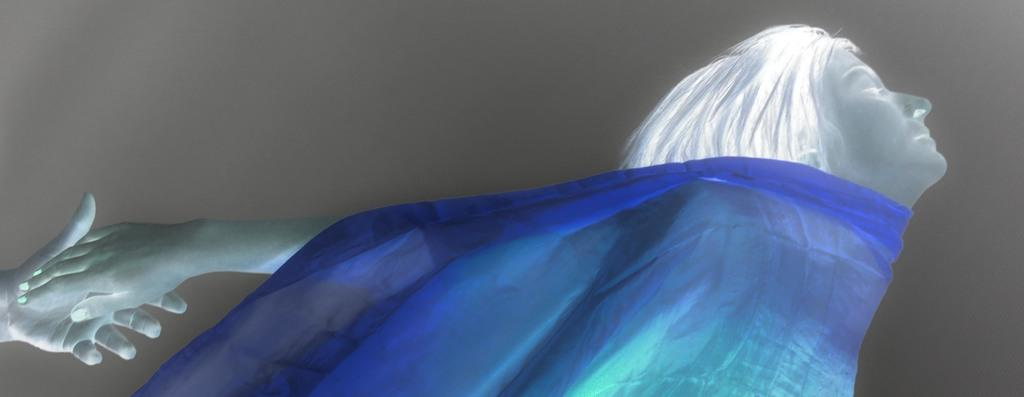Who is present in the image? There is a woman in the image. What material can be seen in the image? There is cloth in the image. What type of game is being played in the image? There is no game present in the image; it only features a woman and cloth. How many times is the cloth being rolled in the image? There is no rolling of cloth in the image; it is simply depicted as a static object. 